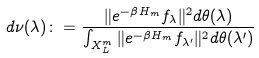<formula> <loc_0><loc_0><loc_500><loc_500>d \nu ( \lambda ) \colon = \frac { \| e ^ { - \beta H _ { m } } f _ { \lambda } \| ^ { 2 } d \theta ( \lambda ) } { \int _ { X _ { L } ^ { m } } \| e ^ { - \beta H _ { m } } f _ { \lambda ^ { \prime } } \| ^ { 2 } d \theta ( \lambda ^ { \prime } ) }</formula> 